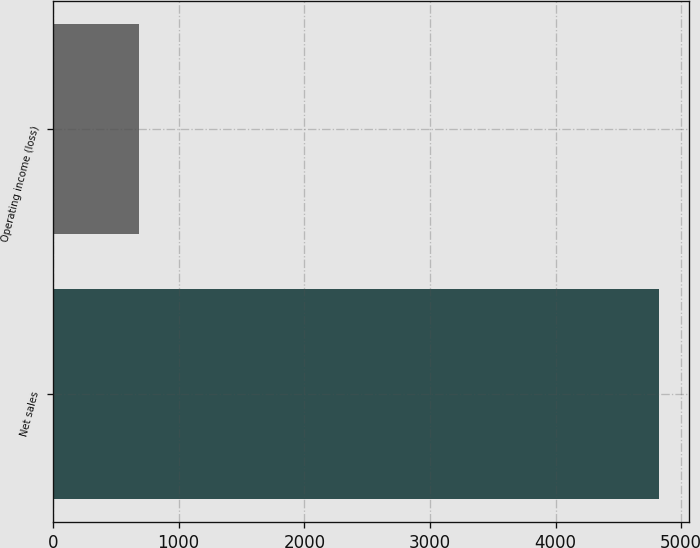Convert chart. <chart><loc_0><loc_0><loc_500><loc_500><bar_chart><fcel>Net sales<fcel>Operating income (loss)<nl><fcel>4820<fcel>682<nl></chart> 